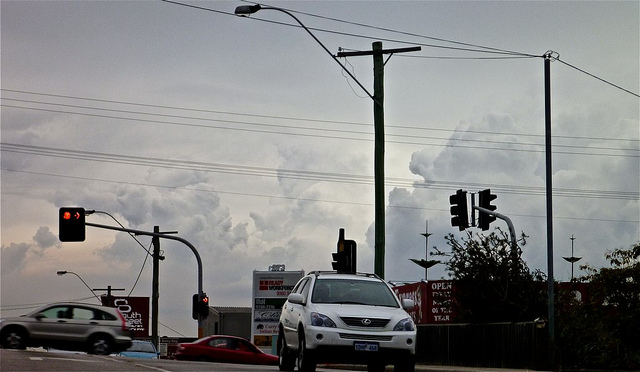Identify the text displayed in this image. CO 